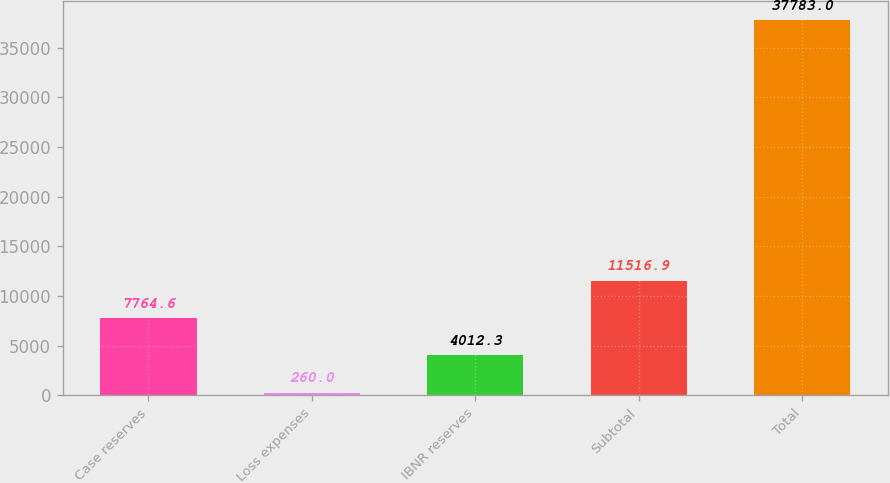<chart> <loc_0><loc_0><loc_500><loc_500><bar_chart><fcel>Case reserves<fcel>Loss expenses<fcel>IBNR reserves<fcel>Subtotal<fcel>Total<nl><fcel>7764.6<fcel>260<fcel>4012.3<fcel>11516.9<fcel>37783<nl></chart> 